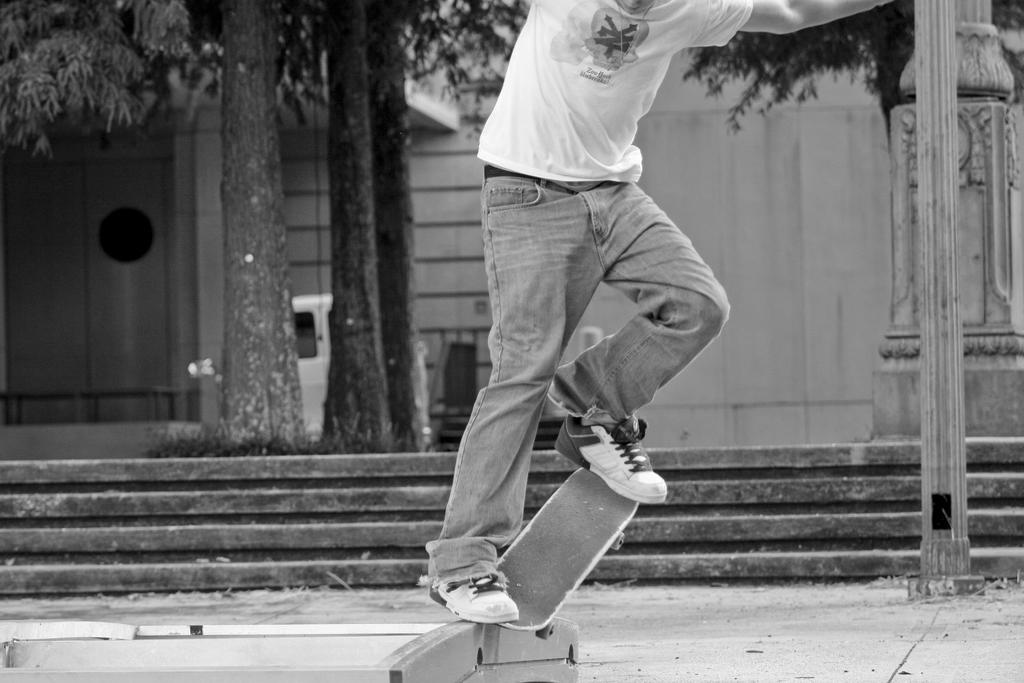Who is the person in the image? There is a man in the image. What is the man doing in the image? The man is skateboarding. What can be seen in the background of the image? There is a building, trees, stairs, doors, and a car in the background of the image. Can you describe the right side of the image? There is a pillar on the right side of the image. What type of coal is being used for digestion at the seashore in the image? There is no coal, digestion, or seashore present in the image. 